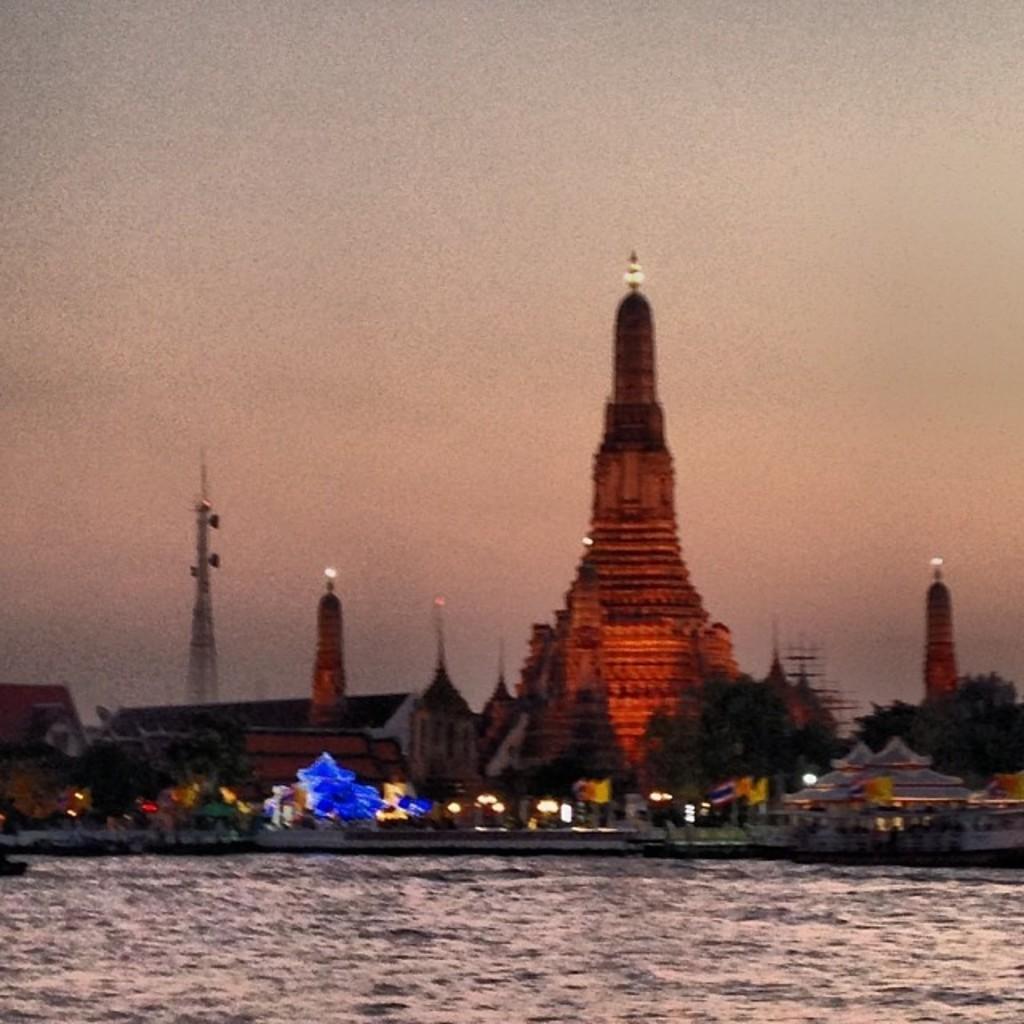In one or two sentences, can you explain what this image depicts? In this image there is a temple and a light attached at the top. And there are a water, Buildings and trees. And at the top there is a sky. 